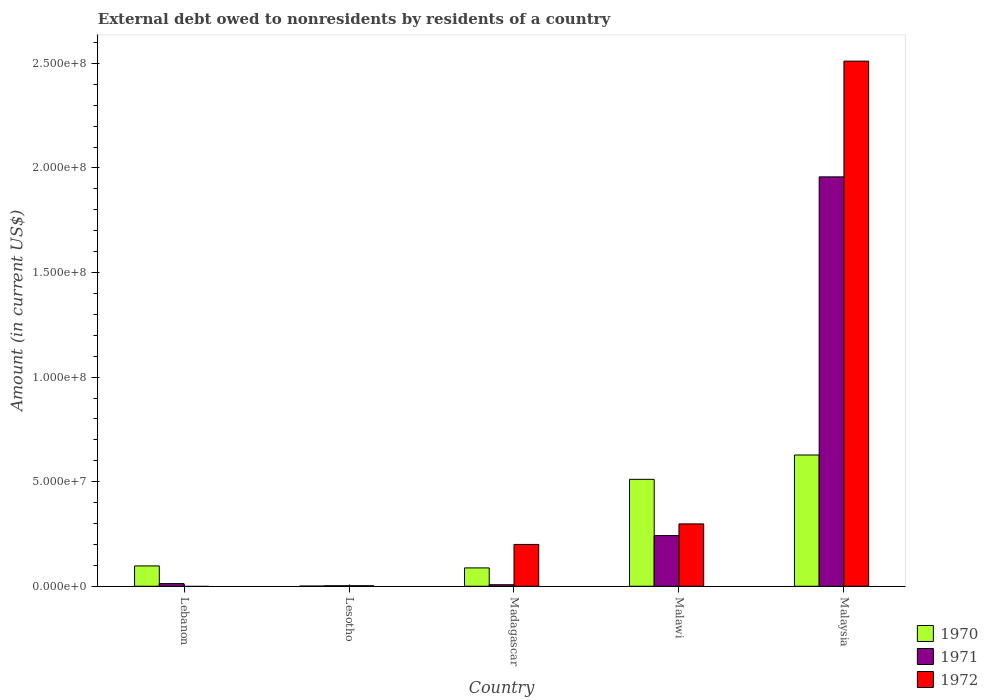How many different coloured bars are there?
Your answer should be very brief. 3. Are the number of bars on each tick of the X-axis equal?
Provide a short and direct response. No. How many bars are there on the 2nd tick from the left?
Provide a succinct answer. 3. How many bars are there on the 1st tick from the right?
Make the answer very short. 3. What is the label of the 1st group of bars from the left?
Your answer should be very brief. Lebanon. In how many cases, is the number of bars for a given country not equal to the number of legend labels?
Your response must be concise. 1. What is the external debt owed by residents in 1971 in Madagascar?
Your response must be concise. 7.30e+05. Across all countries, what is the maximum external debt owed by residents in 1972?
Offer a terse response. 2.51e+08. In which country was the external debt owed by residents in 1971 maximum?
Provide a short and direct response. Malaysia. What is the total external debt owed by residents in 1971 in the graph?
Ensure brevity in your answer.  2.22e+08. What is the difference between the external debt owed by residents in 1970 in Lebanon and that in Madagascar?
Your answer should be compact. 9.51e+05. What is the difference between the external debt owed by residents in 1971 in Lebanon and the external debt owed by residents in 1970 in Malaysia?
Give a very brief answer. -6.15e+07. What is the average external debt owed by residents in 1972 per country?
Your answer should be very brief. 6.02e+07. What is the difference between the external debt owed by residents of/in 1972 and external debt owed by residents of/in 1971 in Madagascar?
Give a very brief answer. 1.93e+07. In how many countries, is the external debt owed by residents in 1971 greater than 180000000 US$?
Provide a succinct answer. 1. What is the ratio of the external debt owed by residents in 1970 in Lesotho to that in Malawi?
Keep it short and to the point. 0. Is the external debt owed by residents in 1971 in Lesotho less than that in Malawi?
Your response must be concise. Yes. Is the difference between the external debt owed by residents in 1972 in Madagascar and Malaysia greater than the difference between the external debt owed by residents in 1971 in Madagascar and Malaysia?
Make the answer very short. No. What is the difference between the highest and the second highest external debt owed by residents in 1970?
Give a very brief answer. 1.16e+07. What is the difference between the highest and the lowest external debt owed by residents in 1971?
Provide a succinct answer. 1.95e+08. In how many countries, is the external debt owed by residents in 1970 greater than the average external debt owed by residents in 1970 taken over all countries?
Your response must be concise. 2. Is the sum of the external debt owed by residents in 1971 in Lebanon and Malawi greater than the maximum external debt owed by residents in 1970 across all countries?
Ensure brevity in your answer.  No. How many bars are there?
Your response must be concise. 14. Are all the bars in the graph horizontal?
Offer a terse response. No. How many countries are there in the graph?
Your response must be concise. 5. What is the difference between two consecutive major ticks on the Y-axis?
Ensure brevity in your answer.  5.00e+07. Does the graph contain grids?
Provide a succinct answer. No. Where does the legend appear in the graph?
Make the answer very short. Bottom right. How are the legend labels stacked?
Make the answer very short. Vertical. What is the title of the graph?
Provide a succinct answer. External debt owed to nonresidents by residents of a country. Does "1990" appear as one of the legend labels in the graph?
Ensure brevity in your answer.  No. What is the label or title of the X-axis?
Your response must be concise. Country. What is the Amount (in current US$) in 1970 in Lebanon?
Offer a very short reply. 9.73e+06. What is the Amount (in current US$) of 1971 in Lebanon?
Ensure brevity in your answer.  1.26e+06. What is the Amount (in current US$) in 1970 in Lesotho?
Your answer should be compact. 7.60e+04. What is the Amount (in current US$) in 1971 in Lesotho?
Offer a terse response. 2.36e+05. What is the Amount (in current US$) in 1972 in Lesotho?
Give a very brief answer. 2.50e+05. What is the Amount (in current US$) of 1970 in Madagascar?
Your response must be concise. 8.78e+06. What is the Amount (in current US$) in 1971 in Madagascar?
Give a very brief answer. 7.30e+05. What is the Amount (in current US$) of 1972 in Madagascar?
Your answer should be very brief. 2.00e+07. What is the Amount (in current US$) of 1970 in Malawi?
Make the answer very short. 5.11e+07. What is the Amount (in current US$) in 1971 in Malawi?
Provide a short and direct response. 2.42e+07. What is the Amount (in current US$) of 1972 in Malawi?
Your answer should be compact. 2.98e+07. What is the Amount (in current US$) of 1970 in Malaysia?
Provide a short and direct response. 6.28e+07. What is the Amount (in current US$) in 1971 in Malaysia?
Your answer should be compact. 1.96e+08. What is the Amount (in current US$) in 1972 in Malaysia?
Provide a short and direct response. 2.51e+08. Across all countries, what is the maximum Amount (in current US$) of 1970?
Offer a terse response. 6.28e+07. Across all countries, what is the maximum Amount (in current US$) in 1971?
Make the answer very short. 1.96e+08. Across all countries, what is the maximum Amount (in current US$) in 1972?
Your response must be concise. 2.51e+08. Across all countries, what is the minimum Amount (in current US$) in 1970?
Provide a succinct answer. 7.60e+04. Across all countries, what is the minimum Amount (in current US$) of 1971?
Provide a short and direct response. 2.36e+05. What is the total Amount (in current US$) of 1970 in the graph?
Offer a terse response. 1.32e+08. What is the total Amount (in current US$) of 1971 in the graph?
Keep it short and to the point. 2.22e+08. What is the total Amount (in current US$) of 1972 in the graph?
Your answer should be compact. 3.01e+08. What is the difference between the Amount (in current US$) of 1970 in Lebanon and that in Lesotho?
Provide a short and direct response. 9.65e+06. What is the difference between the Amount (in current US$) in 1971 in Lebanon and that in Lesotho?
Offer a very short reply. 1.03e+06. What is the difference between the Amount (in current US$) of 1970 in Lebanon and that in Madagascar?
Make the answer very short. 9.51e+05. What is the difference between the Amount (in current US$) in 1971 in Lebanon and that in Madagascar?
Make the answer very short. 5.35e+05. What is the difference between the Amount (in current US$) in 1970 in Lebanon and that in Malawi?
Your answer should be compact. -4.14e+07. What is the difference between the Amount (in current US$) of 1971 in Lebanon and that in Malawi?
Provide a short and direct response. -2.30e+07. What is the difference between the Amount (in current US$) in 1970 in Lebanon and that in Malaysia?
Keep it short and to the point. -5.30e+07. What is the difference between the Amount (in current US$) in 1971 in Lebanon and that in Malaysia?
Offer a terse response. -1.94e+08. What is the difference between the Amount (in current US$) of 1970 in Lesotho and that in Madagascar?
Give a very brief answer. -8.70e+06. What is the difference between the Amount (in current US$) in 1971 in Lesotho and that in Madagascar?
Make the answer very short. -4.94e+05. What is the difference between the Amount (in current US$) in 1972 in Lesotho and that in Madagascar?
Your response must be concise. -1.97e+07. What is the difference between the Amount (in current US$) of 1970 in Lesotho and that in Malawi?
Give a very brief answer. -5.10e+07. What is the difference between the Amount (in current US$) of 1971 in Lesotho and that in Malawi?
Give a very brief answer. -2.40e+07. What is the difference between the Amount (in current US$) in 1972 in Lesotho and that in Malawi?
Keep it short and to the point. -2.96e+07. What is the difference between the Amount (in current US$) of 1970 in Lesotho and that in Malaysia?
Ensure brevity in your answer.  -6.27e+07. What is the difference between the Amount (in current US$) of 1971 in Lesotho and that in Malaysia?
Make the answer very short. -1.95e+08. What is the difference between the Amount (in current US$) in 1972 in Lesotho and that in Malaysia?
Your answer should be compact. -2.51e+08. What is the difference between the Amount (in current US$) in 1970 in Madagascar and that in Malawi?
Make the answer very short. -4.23e+07. What is the difference between the Amount (in current US$) of 1971 in Madagascar and that in Malawi?
Your answer should be very brief. -2.35e+07. What is the difference between the Amount (in current US$) of 1972 in Madagascar and that in Malawi?
Offer a very short reply. -9.82e+06. What is the difference between the Amount (in current US$) of 1970 in Madagascar and that in Malaysia?
Keep it short and to the point. -5.40e+07. What is the difference between the Amount (in current US$) in 1971 in Madagascar and that in Malaysia?
Give a very brief answer. -1.95e+08. What is the difference between the Amount (in current US$) in 1972 in Madagascar and that in Malaysia?
Make the answer very short. -2.31e+08. What is the difference between the Amount (in current US$) of 1970 in Malawi and that in Malaysia?
Your answer should be compact. -1.16e+07. What is the difference between the Amount (in current US$) in 1971 in Malawi and that in Malaysia?
Provide a succinct answer. -1.72e+08. What is the difference between the Amount (in current US$) in 1972 in Malawi and that in Malaysia?
Your answer should be compact. -2.21e+08. What is the difference between the Amount (in current US$) of 1970 in Lebanon and the Amount (in current US$) of 1971 in Lesotho?
Keep it short and to the point. 9.49e+06. What is the difference between the Amount (in current US$) of 1970 in Lebanon and the Amount (in current US$) of 1972 in Lesotho?
Keep it short and to the point. 9.48e+06. What is the difference between the Amount (in current US$) of 1971 in Lebanon and the Amount (in current US$) of 1972 in Lesotho?
Ensure brevity in your answer.  1.02e+06. What is the difference between the Amount (in current US$) of 1970 in Lebanon and the Amount (in current US$) of 1971 in Madagascar?
Your response must be concise. 9.00e+06. What is the difference between the Amount (in current US$) of 1970 in Lebanon and the Amount (in current US$) of 1972 in Madagascar?
Provide a succinct answer. -1.03e+07. What is the difference between the Amount (in current US$) in 1971 in Lebanon and the Amount (in current US$) in 1972 in Madagascar?
Keep it short and to the point. -1.87e+07. What is the difference between the Amount (in current US$) in 1970 in Lebanon and the Amount (in current US$) in 1971 in Malawi?
Provide a short and direct response. -1.45e+07. What is the difference between the Amount (in current US$) in 1970 in Lebanon and the Amount (in current US$) in 1972 in Malawi?
Offer a terse response. -2.01e+07. What is the difference between the Amount (in current US$) in 1971 in Lebanon and the Amount (in current US$) in 1972 in Malawi?
Give a very brief answer. -2.85e+07. What is the difference between the Amount (in current US$) of 1970 in Lebanon and the Amount (in current US$) of 1971 in Malaysia?
Ensure brevity in your answer.  -1.86e+08. What is the difference between the Amount (in current US$) of 1970 in Lebanon and the Amount (in current US$) of 1972 in Malaysia?
Offer a terse response. -2.41e+08. What is the difference between the Amount (in current US$) of 1971 in Lebanon and the Amount (in current US$) of 1972 in Malaysia?
Make the answer very short. -2.50e+08. What is the difference between the Amount (in current US$) in 1970 in Lesotho and the Amount (in current US$) in 1971 in Madagascar?
Provide a short and direct response. -6.54e+05. What is the difference between the Amount (in current US$) in 1970 in Lesotho and the Amount (in current US$) in 1972 in Madagascar?
Give a very brief answer. -1.99e+07. What is the difference between the Amount (in current US$) of 1971 in Lesotho and the Amount (in current US$) of 1972 in Madagascar?
Provide a short and direct response. -1.98e+07. What is the difference between the Amount (in current US$) in 1970 in Lesotho and the Amount (in current US$) in 1971 in Malawi?
Keep it short and to the point. -2.42e+07. What is the difference between the Amount (in current US$) in 1970 in Lesotho and the Amount (in current US$) in 1972 in Malawi?
Provide a short and direct response. -2.97e+07. What is the difference between the Amount (in current US$) of 1971 in Lesotho and the Amount (in current US$) of 1972 in Malawi?
Offer a terse response. -2.96e+07. What is the difference between the Amount (in current US$) in 1970 in Lesotho and the Amount (in current US$) in 1971 in Malaysia?
Make the answer very short. -1.96e+08. What is the difference between the Amount (in current US$) in 1970 in Lesotho and the Amount (in current US$) in 1972 in Malaysia?
Provide a succinct answer. -2.51e+08. What is the difference between the Amount (in current US$) in 1971 in Lesotho and the Amount (in current US$) in 1972 in Malaysia?
Give a very brief answer. -2.51e+08. What is the difference between the Amount (in current US$) in 1970 in Madagascar and the Amount (in current US$) in 1971 in Malawi?
Keep it short and to the point. -1.55e+07. What is the difference between the Amount (in current US$) of 1970 in Madagascar and the Amount (in current US$) of 1972 in Malawi?
Your response must be concise. -2.10e+07. What is the difference between the Amount (in current US$) in 1971 in Madagascar and the Amount (in current US$) in 1972 in Malawi?
Your answer should be very brief. -2.91e+07. What is the difference between the Amount (in current US$) of 1970 in Madagascar and the Amount (in current US$) of 1971 in Malaysia?
Offer a terse response. -1.87e+08. What is the difference between the Amount (in current US$) of 1970 in Madagascar and the Amount (in current US$) of 1972 in Malaysia?
Keep it short and to the point. -2.42e+08. What is the difference between the Amount (in current US$) in 1971 in Madagascar and the Amount (in current US$) in 1972 in Malaysia?
Your answer should be compact. -2.50e+08. What is the difference between the Amount (in current US$) of 1970 in Malawi and the Amount (in current US$) of 1971 in Malaysia?
Your answer should be very brief. -1.45e+08. What is the difference between the Amount (in current US$) in 1970 in Malawi and the Amount (in current US$) in 1972 in Malaysia?
Make the answer very short. -2.00e+08. What is the difference between the Amount (in current US$) in 1971 in Malawi and the Amount (in current US$) in 1972 in Malaysia?
Give a very brief answer. -2.27e+08. What is the average Amount (in current US$) of 1970 per country?
Provide a succinct answer. 2.65e+07. What is the average Amount (in current US$) in 1971 per country?
Make the answer very short. 4.44e+07. What is the average Amount (in current US$) in 1972 per country?
Provide a short and direct response. 6.02e+07. What is the difference between the Amount (in current US$) of 1970 and Amount (in current US$) of 1971 in Lebanon?
Ensure brevity in your answer.  8.46e+06. What is the difference between the Amount (in current US$) in 1970 and Amount (in current US$) in 1971 in Lesotho?
Keep it short and to the point. -1.60e+05. What is the difference between the Amount (in current US$) in 1970 and Amount (in current US$) in 1972 in Lesotho?
Keep it short and to the point. -1.74e+05. What is the difference between the Amount (in current US$) in 1971 and Amount (in current US$) in 1972 in Lesotho?
Make the answer very short. -1.40e+04. What is the difference between the Amount (in current US$) of 1970 and Amount (in current US$) of 1971 in Madagascar?
Make the answer very short. 8.04e+06. What is the difference between the Amount (in current US$) in 1970 and Amount (in current US$) in 1972 in Madagascar?
Provide a succinct answer. -1.12e+07. What is the difference between the Amount (in current US$) of 1971 and Amount (in current US$) of 1972 in Madagascar?
Offer a terse response. -1.93e+07. What is the difference between the Amount (in current US$) of 1970 and Amount (in current US$) of 1971 in Malawi?
Your answer should be compact. 2.69e+07. What is the difference between the Amount (in current US$) of 1970 and Amount (in current US$) of 1972 in Malawi?
Give a very brief answer. 2.13e+07. What is the difference between the Amount (in current US$) in 1971 and Amount (in current US$) in 1972 in Malawi?
Offer a terse response. -5.59e+06. What is the difference between the Amount (in current US$) in 1970 and Amount (in current US$) in 1971 in Malaysia?
Ensure brevity in your answer.  -1.33e+08. What is the difference between the Amount (in current US$) in 1970 and Amount (in current US$) in 1972 in Malaysia?
Keep it short and to the point. -1.88e+08. What is the difference between the Amount (in current US$) in 1971 and Amount (in current US$) in 1972 in Malaysia?
Make the answer very short. -5.53e+07. What is the ratio of the Amount (in current US$) of 1970 in Lebanon to that in Lesotho?
Ensure brevity in your answer.  127.97. What is the ratio of the Amount (in current US$) of 1971 in Lebanon to that in Lesotho?
Offer a terse response. 5.36. What is the ratio of the Amount (in current US$) of 1970 in Lebanon to that in Madagascar?
Ensure brevity in your answer.  1.11. What is the ratio of the Amount (in current US$) in 1971 in Lebanon to that in Madagascar?
Keep it short and to the point. 1.73. What is the ratio of the Amount (in current US$) in 1970 in Lebanon to that in Malawi?
Make the answer very short. 0.19. What is the ratio of the Amount (in current US$) in 1971 in Lebanon to that in Malawi?
Make the answer very short. 0.05. What is the ratio of the Amount (in current US$) in 1970 in Lebanon to that in Malaysia?
Ensure brevity in your answer.  0.15. What is the ratio of the Amount (in current US$) in 1971 in Lebanon to that in Malaysia?
Your answer should be very brief. 0.01. What is the ratio of the Amount (in current US$) in 1970 in Lesotho to that in Madagascar?
Give a very brief answer. 0.01. What is the ratio of the Amount (in current US$) of 1971 in Lesotho to that in Madagascar?
Provide a succinct answer. 0.32. What is the ratio of the Amount (in current US$) of 1972 in Lesotho to that in Madagascar?
Your response must be concise. 0.01. What is the ratio of the Amount (in current US$) in 1970 in Lesotho to that in Malawi?
Provide a succinct answer. 0. What is the ratio of the Amount (in current US$) of 1971 in Lesotho to that in Malawi?
Your response must be concise. 0.01. What is the ratio of the Amount (in current US$) in 1972 in Lesotho to that in Malawi?
Offer a terse response. 0.01. What is the ratio of the Amount (in current US$) in 1970 in Lesotho to that in Malaysia?
Offer a very short reply. 0. What is the ratio of the Amount (in current US$) of 1971 in Lesotho to that in Malaysia?
Offer a very short reply. 0. What is the ratio of the Amount (in current US$) in 1970 in Madagascar to that in Malawi?
Offer a very short reply. 0.17. What is the ratio of the Amount (in current US$) of 1971 in Madagascar to that in Malawi?
Keep it short and to the point. 0.03. What is the ratio of the Amount (in current US$) of 1972 in Madagascar to that in Malawi?
Your response must be concise. 0.67. What is the ratio of the Amount (in current US$) of 1970 in Madagascar to that in Malaysia?
Offer a very short reply. 0.14. What is the ratio of the Amount (in current US$) in 1971 in Madagascar to that in Malaysia?
Keep it short and to the point. 0. What is the ratio of the Amount (in current US$) of 1972 in Madagascar to that in Malaysia?
Your answer should be compact. 0.08. What is the ratio of the Amount (in current US$) in 1970 in Malawi to that in Malaysia?
Ensure brevity in your answer.  0.81. What is the ratio of the Amount (in current US$) in 1971 in Malawi to that in Malaysia?
Provide a short and direct response. 0.12. What is the ratio of the Amount (in current US$) of 1972 in Malawi to that in Malaysia?
Your answer should be very brief. 0.12. What is the difference between the highest and the second highest Amount (in current US$) of 1970?
Offer a terse response. 1.16e+07. What is the difference between the highest and the second highest Amount (in current US$) of 1971?
Your response must be concise. 1.72e+08. What is the difference between the highest and the second highest Amount (in current US$) in 1972?
Your answer should be compact. 2.21e+08. What is the difference between the highest and the lowest Amount (in current US$) in 1970?
Your answer should be compact. 6.27e+07. What is the difference between the highest and the lowest Amount (in current US$) of 1971?
Your answer should be very brief. 1.95e+08. What is the difference between the highest and the lowest Amount (in current US$) of 1972?
Ensure brevity in your answer.  2.51e+08. 